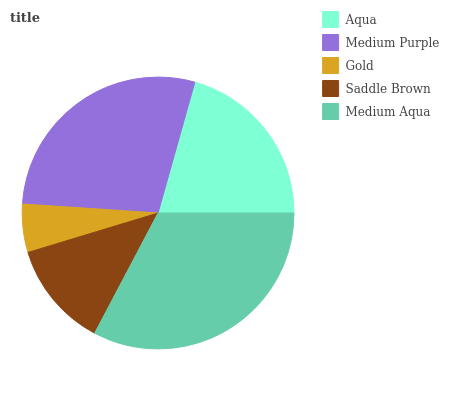Is Gold the minimum?
Answer yes or no. Yes. Is Medium Aqua the maximum?
Answer yes or no. Yes. Is Medium Purple the minimum?
Answer yes or no. No. Is Medium Purple the maximum?
Answer yes or no. No. Is Medium Purple greater than Aqua?
Answer yes or no. Yes. Is Aqua less than Medium Purple?
Answer yes or no. Yes. Is Aqua greater than Medium Purple?
Answer yes or no. No. Is Medium Purple less than Aqua?
Answer yes or no. No. Is Aqua the high median?
Answer yes or no. Yes. Is Aqua the low median?
Answer yes or no. Yes. Is Gold the high median?
Answer yes or no. No. Is Medium Purple the low median?
Answer yes or no. No. 